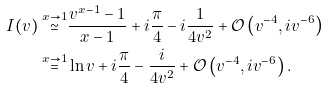Convert formula to latex. <formula><loc_0><loc_0><loc_500><loc_500>I ( v ) \stackrel { x \to 1 } { \simeq } & \frac { v ^ { x - 1 } - 1 } { x - 1 } + i \frac { \pi } { 4 } - i \frac { 1 } { 4 v ^ { 2 } } + \mathcal { O } \left ( v ^ { - 4 } , i v ^ { - 6 } \right ) \\ \stackrel { x \to 1 } { = } & \ln v + i \frac { \pi } { 4 } - \frac { i } { 4 v ^ { 2 } } + \mathcal { O } \left ( v ^ { - 4 } , i v ^ { - 6 } \right ) .</formula> 